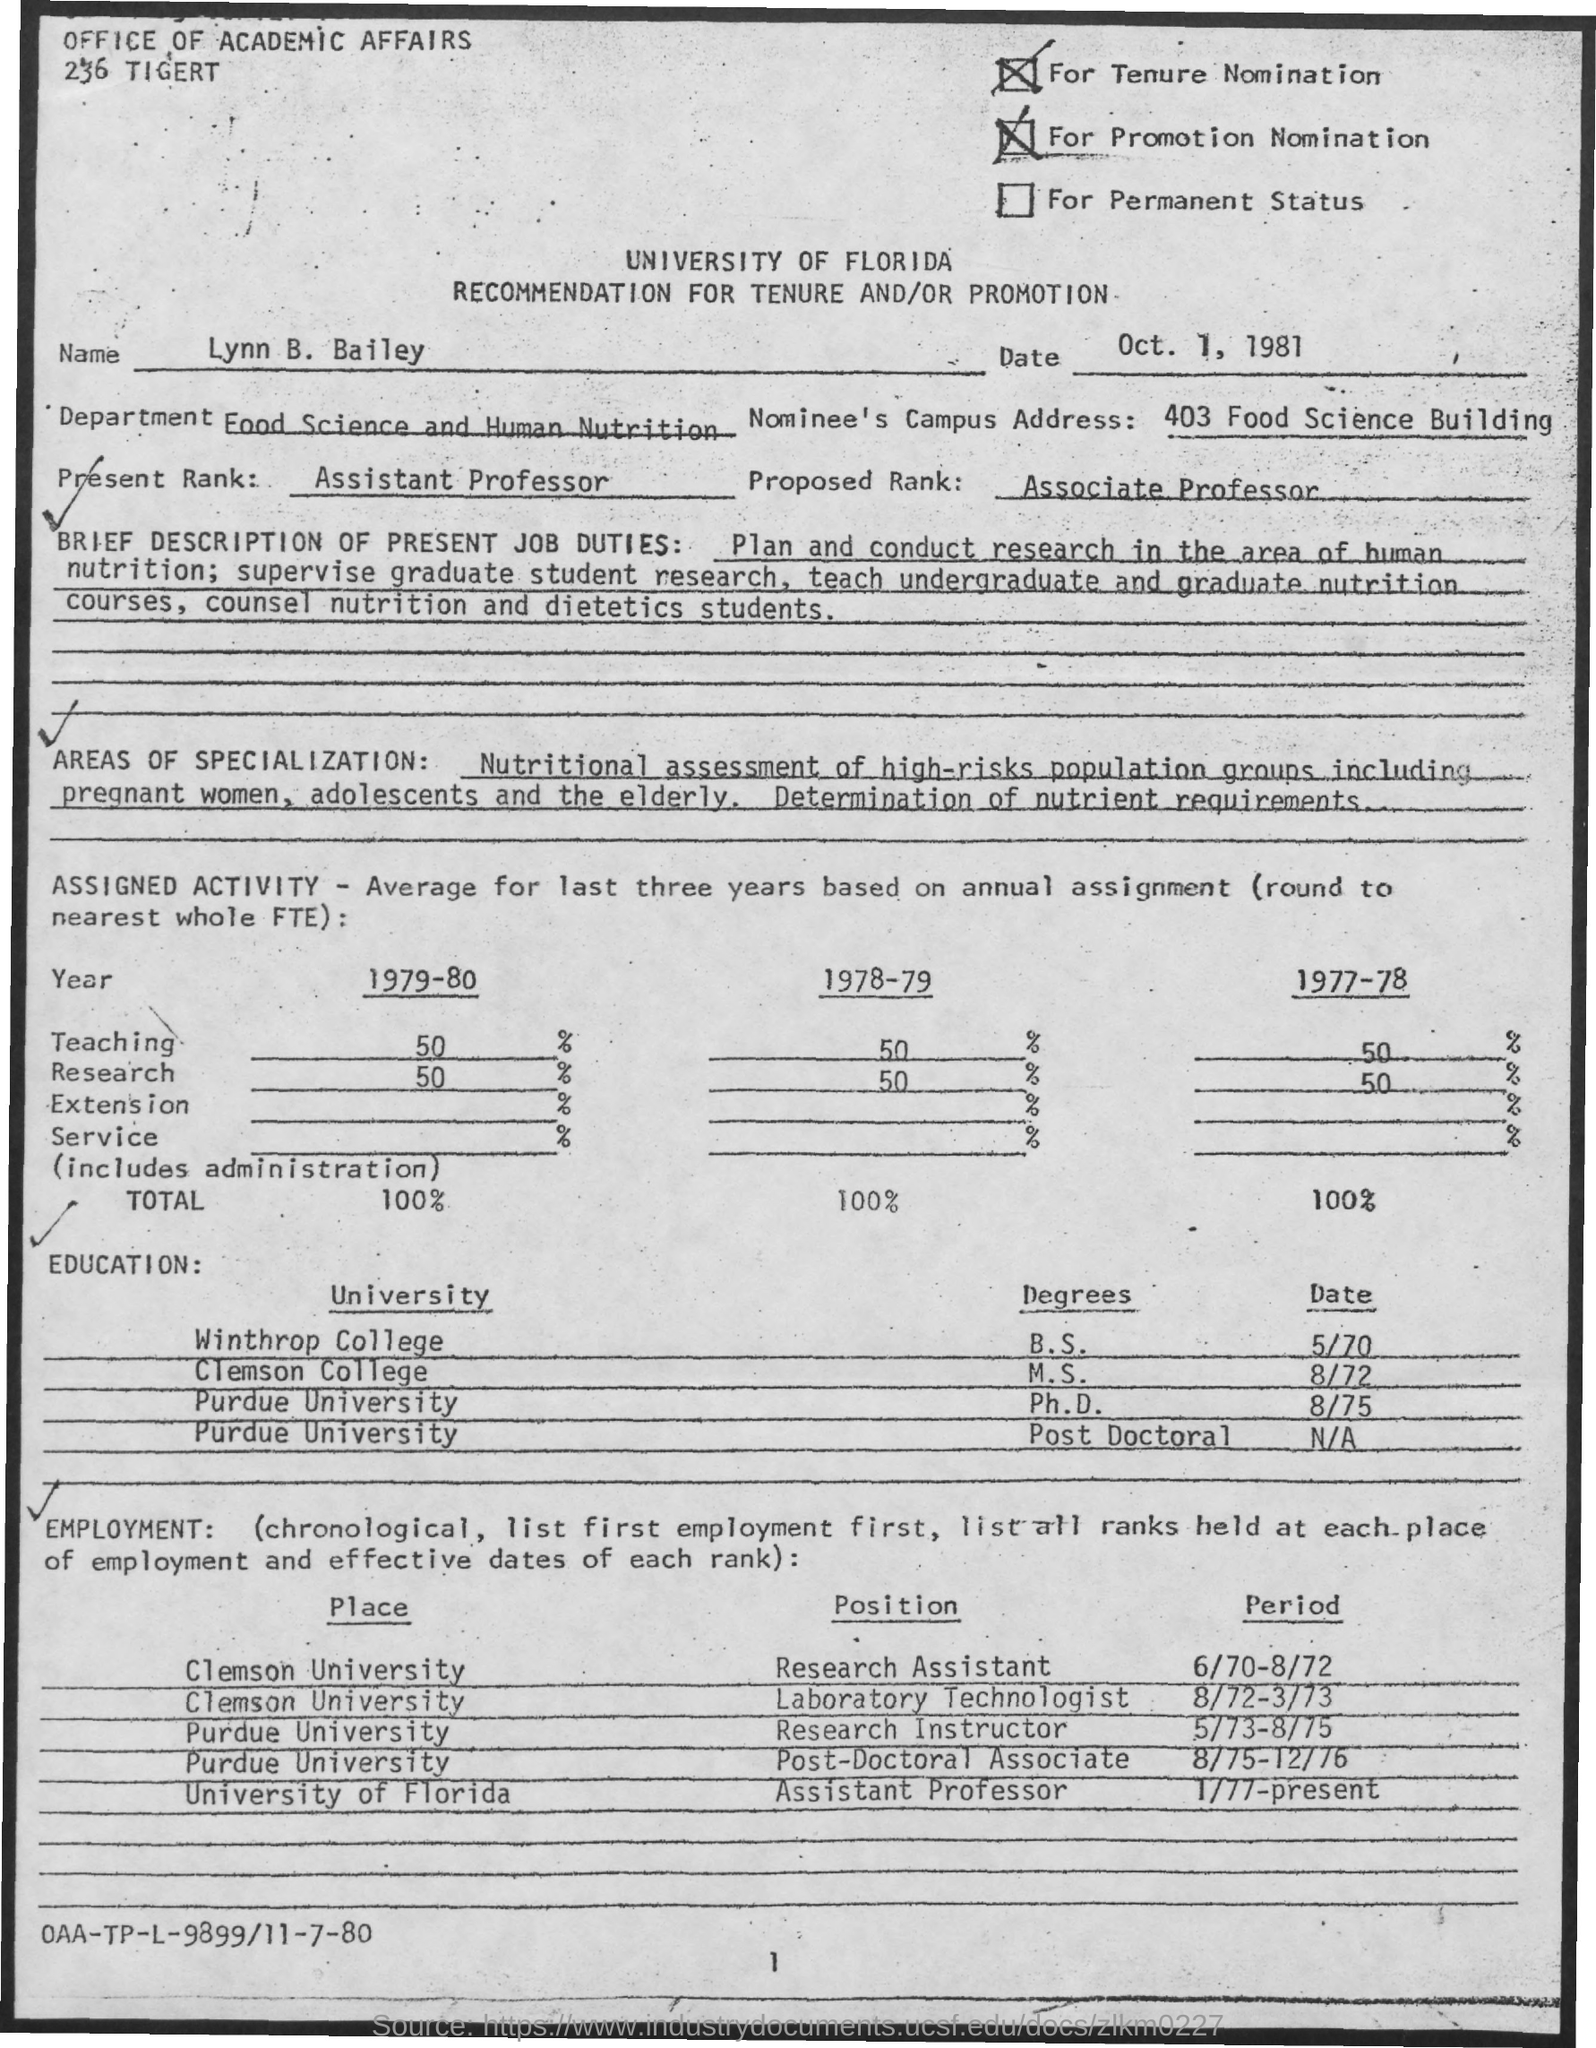Draw attention to some important aspects in this diagram. Lynn B. Bailey completed her Ph.D. at Purdue University. Lynn B. Bailey served as a Research Assistant at Clemson University from June 70 to August 72. The issued date of this document is October 1, 1981. The nominee's campus address, as listed in the document, is 403 Food Science Building. Lynn B. Bailey is employed in the Food Science and Human Nutrition department. 